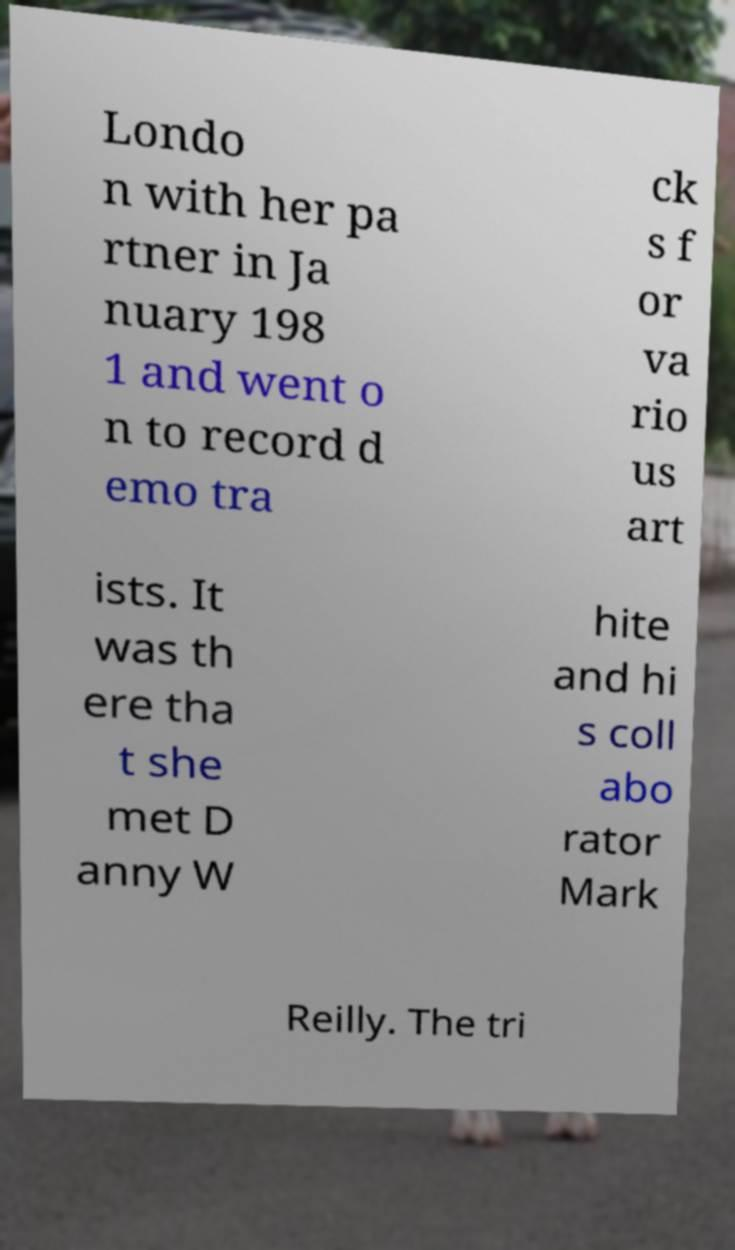Could you extract and type out the text from this image? Londo n with her pa rtner in Ja nuary 198 1 and went o n to record d emo tra ck s f or va rio us art ists. It was th ere tha t she met D anny W hite and hi s coll abo rator Mark Reilly. The tri 